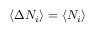Convert formula to latex. <formula><loc_0><loc_0><loc_500><loc_500>\left \langle \Delta N _ { i } \right \rangle = \left \langle N _ { i } \right \rangle</formula> 